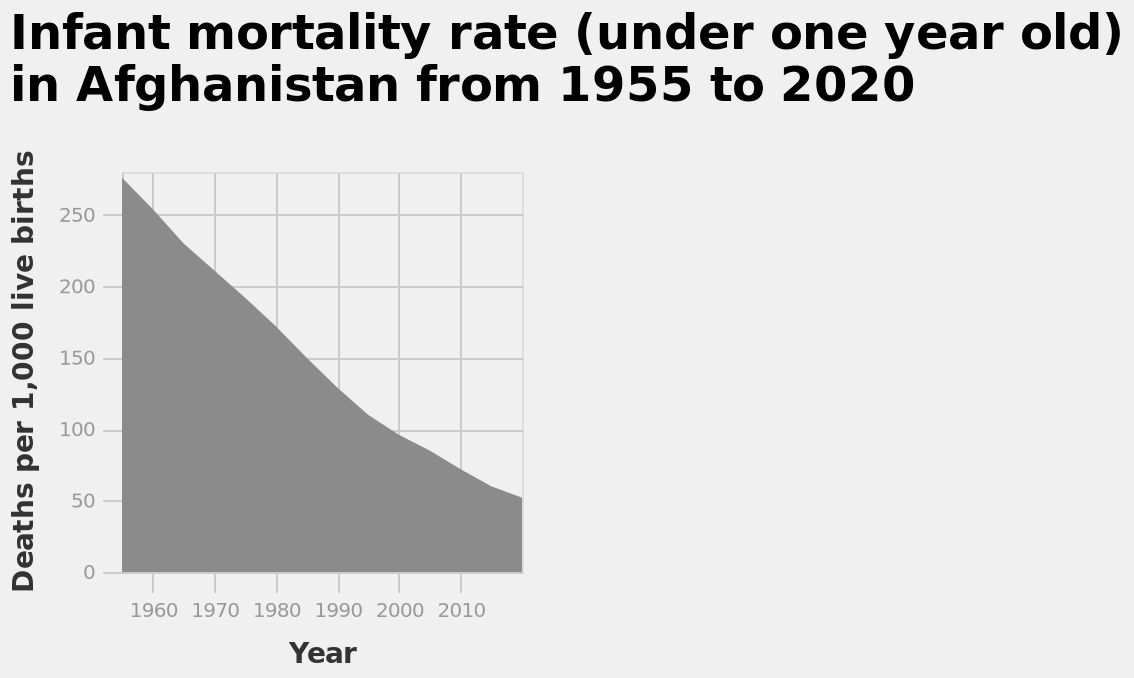<image>
What is the range of years plotted on the x-axis of the infant mortality rate chart for Afghanistan? The x-axis represents the years from 1955 to 2020, with a linear scale from 1960 to 2010. How is the infant mortality rate represented in the chart for Afghanistan? The infant mortality rate is represented as an area chart, with the y-axis showing the deaths per 1,000 live births and the x-axis showing the years. Describe the following image in detail Infant mortality rate (under one year old) in Afghanistan from 1955 to 2020 is a area chart. Year is plotted on a linear scale from 1960 to 2010 on the x-axis. On the y-axis, Deaths per 1,000 live births is drawn along a linear scale of range 0 to 250. 